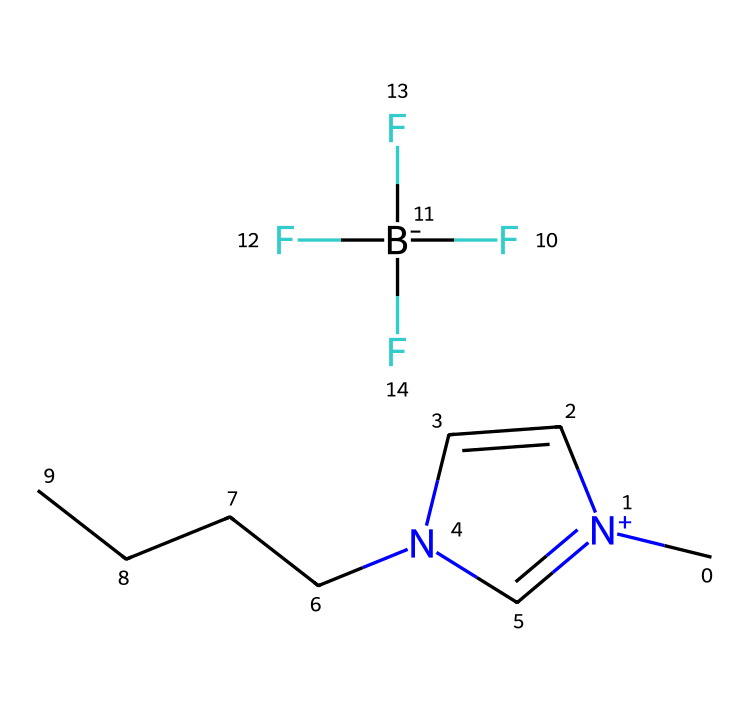What type of functional groups are present in this ionic liquid? The structure contains a quaternary ammonium group derived from the nitrogen atom connected to alkyl chains and a tetrafluoroborate anion indicated by the presence of BF4.
Answer: quaternary ammonium and tetrafluoroborate How many carbon atoms are in the structure? By counting the carbon atoms in the SMILES notation, there are four carbons in the CCCC chain and three in the aromatic ring and the nitrogen-connected carbon, giving a total of seven.
Answer: seven What is the primary purpose of this ionic liquid in film preservation? Ionic liquids like this are known for their excellent solubilizing capabilities and stability, making them suitable for preserving the integrity and longevity of film materials.
Answer: preservation Which element is present as a tetrahedral anion in this ionic liquid? The presence of F[B-](F)(F)F suggests that boron is the central atom surrounded by four fluorine atoms in a tetrahedral arrangement.
Answer: boron What type of interactions are likely to occur due to the ionic nature of this liquid? The ionic nature allows for strong electrostatic interactions between the cation and the anion, leading to unique properties like low volatility and high thermal stability.
Answer: electrostatic interactions 